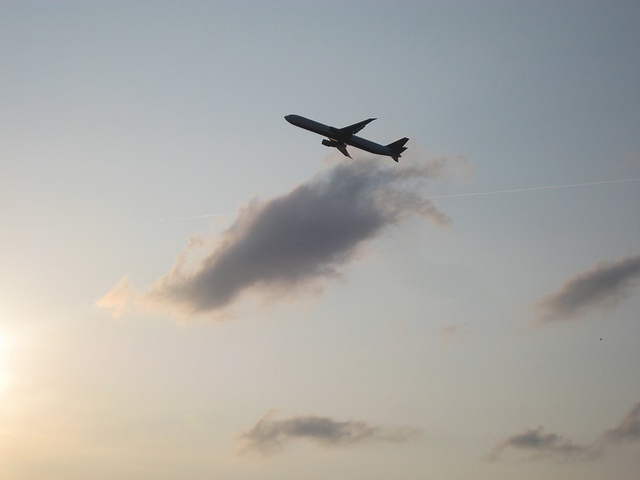Describe the objects in this image and their specific colors. I can see a airplane in darkgray, black, and gray tones in this image. 